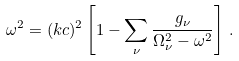Convert formula to latex. <formula><loc_0><loc_0><loc_500><loc_500>\omega ^ { 2 } = ( k c ) ^ { 2 } \left [ 1 - \sum _ { \nu } \frac { g _ { \nu } } { \Omega _ { \nu } ^ { 2 } - \omega ^ { 2 } } \right ] \, .</formula> 